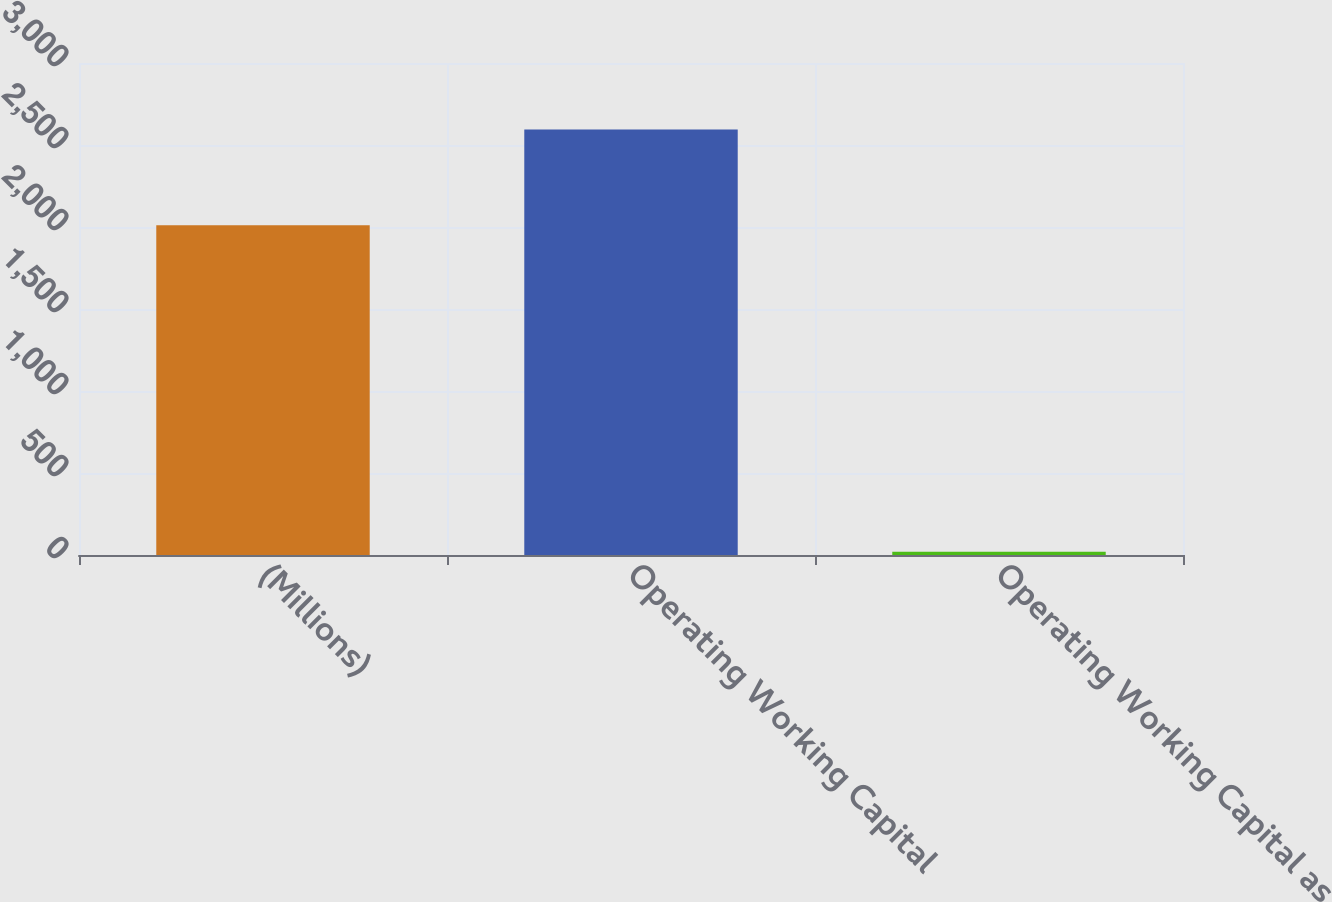<chart> <loc_0><loc_0><loc_500><loc_500><bar_chart><fcel>(Millions)<fcel>Operating Working Capital<fcel>Operating Working Capital as<nl><fcel>2010<fcel>2595<fcel>19.2<nl></chart> 